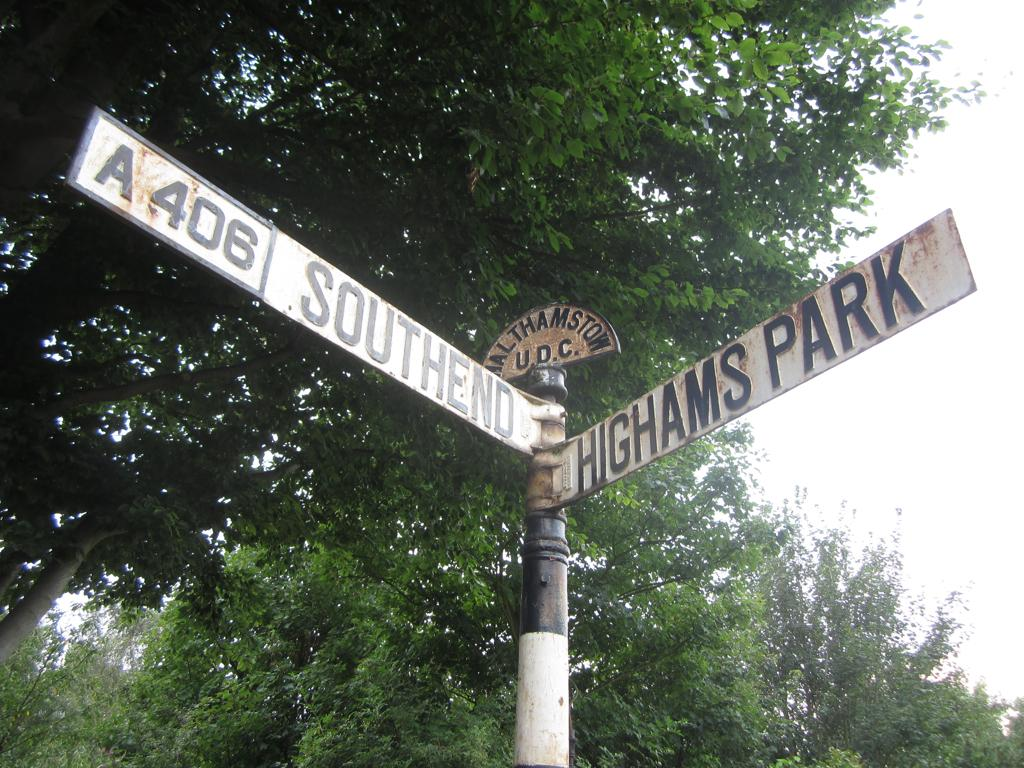What type of view is shown in the image? The image has an outside view. What is located in the foreground of the image? There is a sign board in the foreground. What can be seen on the right side of the image? The sky is visible on the right side of the image. What is visible in the background of the image? There are trees in the background. What theory is being proposed on the sign board in the image? There is no theory mentioned on the sign board in the image; it is simply a sign board without any text or information about a theory. 